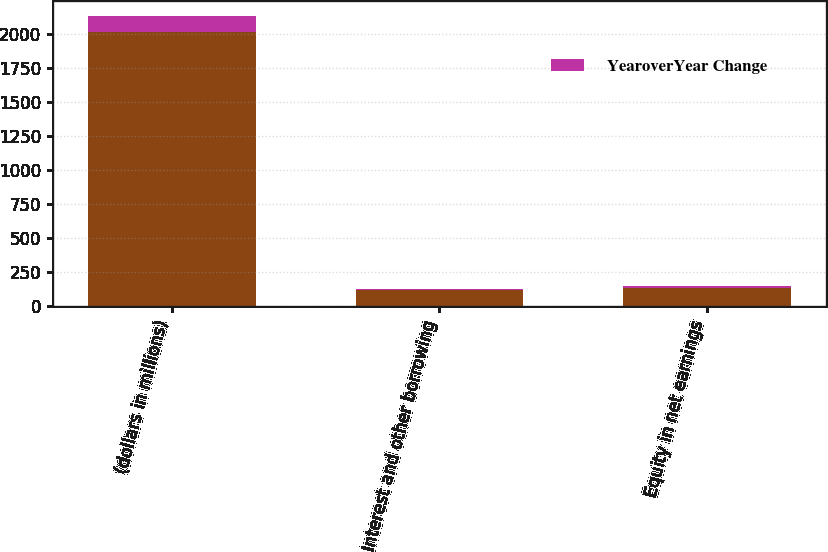<chart> <loc_0><loc_0><loc_500><loc_500><stacked_bar_chart><ecel><fcel>(dollars in millions)<fcel>Interest and other borrowing<fcel>Equity in net earnings<nl><fcel>nan<fcel>2017<fcel>117<fcel>129.2<nl><fcel>YearoverYear Change<fcel>117<fcel>5<fcel>17<nl></chart> 